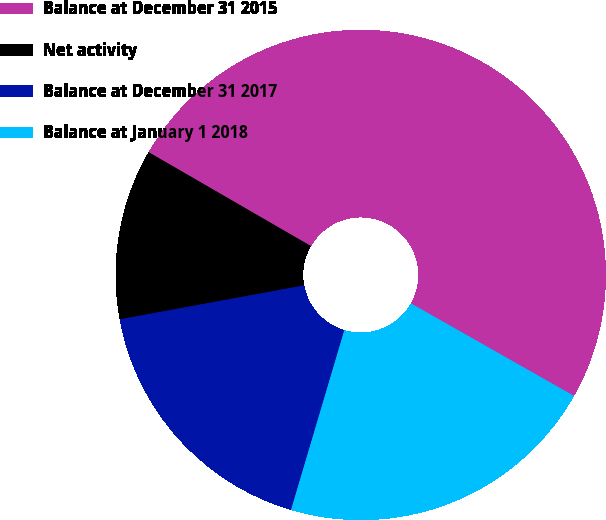Convert chart. <chart><loc_0><loc_0><loc_500><loc_500><pie_chart><fcel>Balance at December 31 2015<fcel>Net activity<fcel>Balance at December 31 2017<fcel>Balance at January 1 2018<nl><fcel>49.87%<fcel>11.25%<fcel>17.51%<fcel>21.37%<nl></chart> 